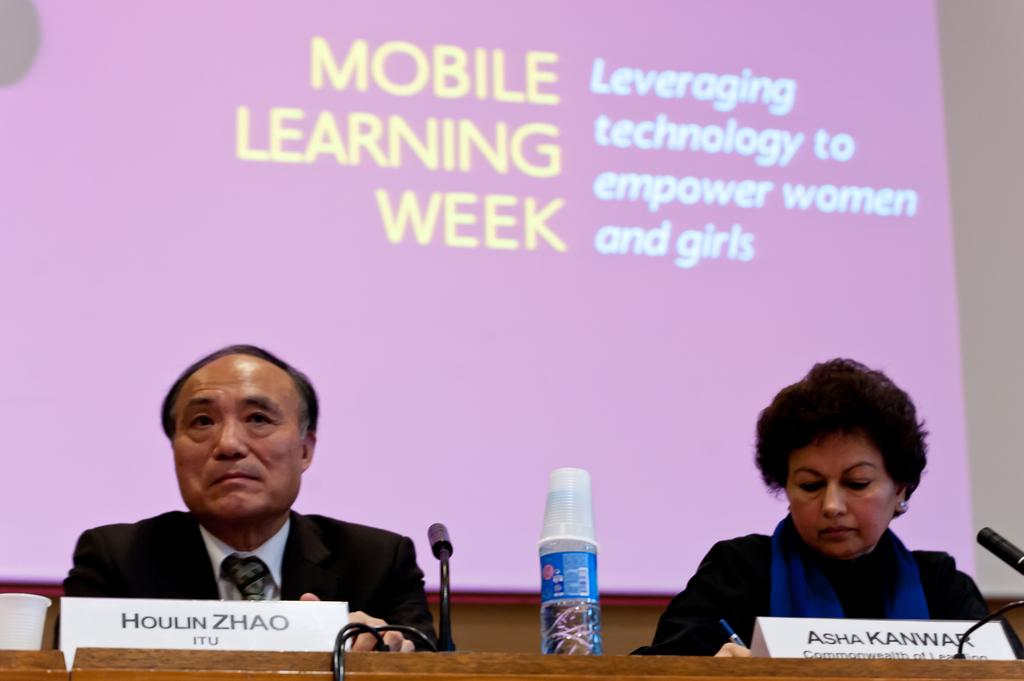What are they leveraging?
Offer a very short reply. Technology. 